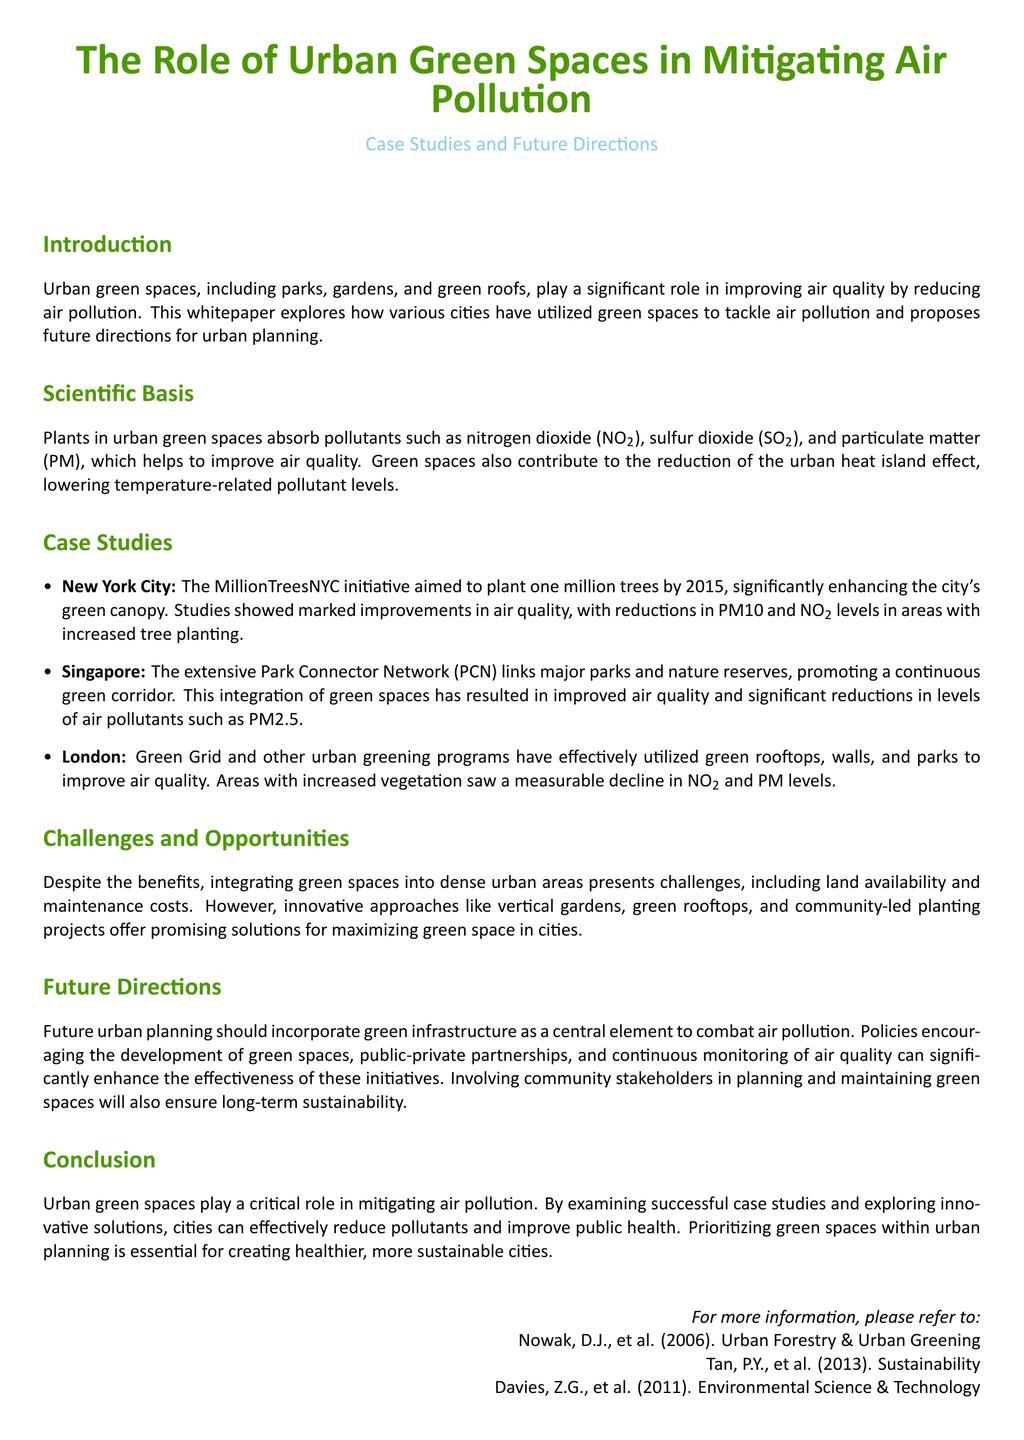What is the main focus of the whitepaper? The main focus of the whitepaper is on the role of urban green spaces in improving air quality and mitigating air pollution.
Answer: urban green spaces Which city aimed to plant one million trees by 2015? The city that aimed to plant one million trees by 2015 is New York City, as noted in the case studies.
Answer: New York City What is one benefit of urban green spaces mentioned? One benefit mentioned is that plants in urban green spaces absorb pollutants such as nitrogen dioxide and particulate matter, improving air quality.
Answer: absorb pollutants What type of green initiative is highlighted in Singapore? The initiative highlighted in Singapore is the Park Connector Network, which promotes continuous green corridors linking major parks.
Answer: Park Connector Network What are two pollutants that urban green spaces help reduce? The two pollutants that urban green spaces help reduce are nitrogen dioxide and particulate matter.
Answer: nitrogen dioxide, particulate matter What percentage of air pollutants was reported to decrease in areas with increased tree planting in New York City? The whitepaper does not specify the percentage of air pollutants that decreased; it simply states marked improvements in air quality.
Answer: not specified What is a key challenge mentioned in integrating green spaces into cities? A key challenge mentioned is land availability, which complicates the integration of green spaces in dense urban areas.
Answer: land availability What does the whitepaper suggest about future urban planning? The whitepaper suggests that future urban planning should incorporate green infrastructure as a central element to combat air pollution.
Answer: green infrastructure 